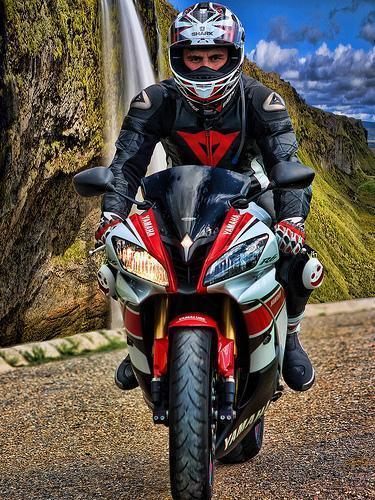How many headlights are on?
Give a very brief answer. 1. How many mirrors does the motorcycle have?
Give a very brief answer. 2. 